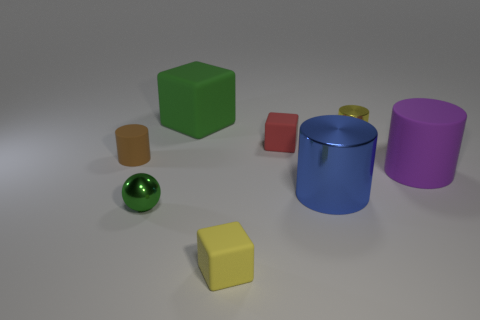Subtract all tiny red rubber blocks. How many blocks are left? 2 Add 1 big yellow metal balls. How many objects exist? 9 Subtract all blue cylinders. How many cylinders are left? 3 Subtract all brown cubes. Subtract all blue cylinders. How many cubes are left? 3 Subtract all purple cylinders. How many brown spheres are left? 0 Subtract all cylinders. Subtract all tiny yellow blocks. How many objects are left? 3 Add 4 rubber cylinders. How many rubber cylinders are left? 6 Add 6 big cubes. How many big cubes exist? 7 Subtract 1 red cubes. How many objects are left? 7 Subtract all spheres. How many objects are left? 7 